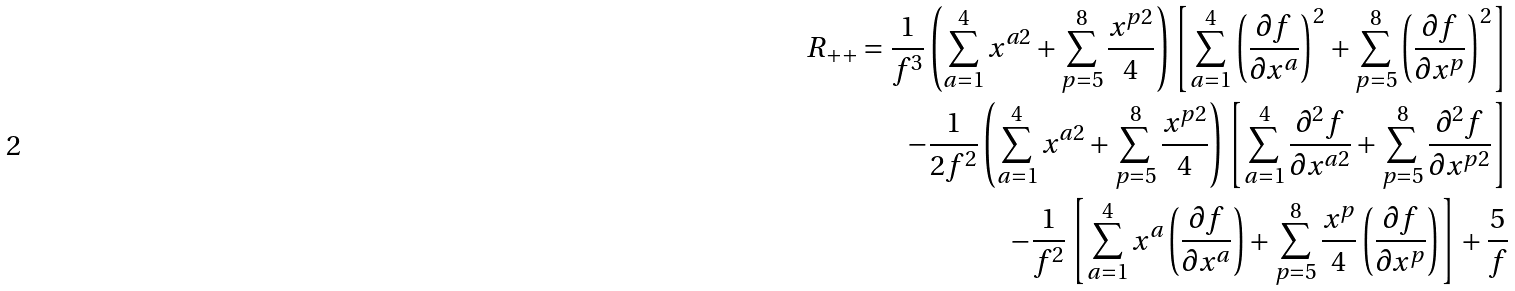<formula> <loc_0><loc_0><loc_500><loc_500>R _ { + + } = \frac { 1 } { f ^ { 3 } } \left ( \sum _ { a = 1 } ^ { 4 } x ^ { a 2 } + \sum _ { p = 5 } ^ { 8 } \frac { x ^ { p 2 } } { 4 } \right ) \left [ \sum _ { a = 1 } ^ { 4 } \left ( \frac { \partial f } { \partial x ^ { a } } \right ) ^ { 2 } + \sum _ { p = 5 } ^ { 8 } \left ( \frac { \partial f } { \partial x ^ { p } } \right ) ^ { 2 } \right ] \\ - \frac { 1 } { 2 f ^ { 2 } } \left ( \sum _ { a = 1 } ^ { 4 } x ^ { a 2 } + \sum _ { p = 5 } ^ { 8 } \frac { x ^ { p 2 } } { 4 } \right ) \left [ \sum _ { a = 1 } ^ { 4 } \frac { \partial ^ { 2 } f } { \partial x ^ { a 2 } } + \sum _ { p = 5 } ^ { 8 } \frac { \partial ^ { 2 } f } { \partial x ^ { p 2 } } \right ] \\ - \frac { 1 } { f ^ { 2 } } \left [ \sum _ { a = 1 } ^ { 4 } x ^ { a } \left ( \frac { \partial f } { \partial x ^ { a } } \right ) + \sum _ { p = 5 } ^ { 8 } \frac { x ^ { p } } { 4 } \left ( \frac { \partial f } { \partial x ^ { p } } \right ) \right ] + \frac { 5 } { f }</formula> 